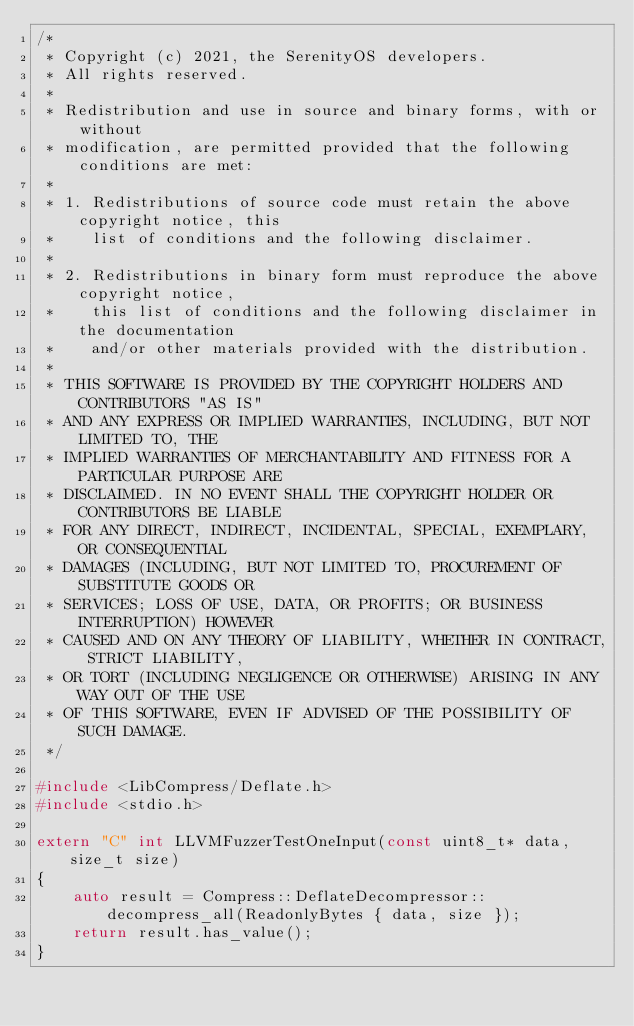Convert code to text. <code><loc_0><loc_0><loc_500><loc_500><_C++_>/*
 * Copyright (c) 2021, the SerenityOS developers.
 * All rights reserved.
 *
 * Redistribution and use in source and binary forms, with or without
 * modification, are permitted provided that the following conditions are met:
 *
 * 1. Redistributions of source code must retain the above copyright notice, this
 *    list of conditions and the following disclaimer.
 *
 * 2. Redistributions in binary form must reproduce the above copyright notice,
 *    this list of conditions and the following disclaimer in the documentation
 *    and/or other materials provided with the distribution.
 *
 * THIS SOFTWARE IS PROVIDED BY THE COPYRIGHT HOLDERS AND CONTRIBUTORS "AS IS"
 * AND ANY EXPRESS OR IMPLIED WARRANTIES, INCLUDING, BUT NOT LIMITED TO, THE
 * IMPLIED WARRANTIES OF MERCHANTABILITY AND FITNESS FOR A PARTICULAR PURPOSE ARE
 * DISCLAIMED. IN NO EVENT SHALL THE COPYRIGHT HOLDER OR CONTRIBUTORS BE LIABLE
 * FOR ANY DIRECT, INDIRECT, INCIDENTAL, SPECIAL, EXEMPLARY, OR CONSEQUENTIAL
 * DAMAGES (INCLUDING, BUT NOT LIMITED TO, PROCUREMENT OF SUBSTITUTE GOODS OR
 * SERVICES; LOSS OF USE, DATA, OR PROFITS; OR BUSINESS INTERRUPTION) HOWEVER
 * CAUSED AND ON ANY THEORY OF LIABILITY, WHETHER IN CONTRACT, STRICT LIABILITY,
 * OR TORT (INCLUDING NEGLIGENCE OR OTHERWISE) ARISING IN ANY WAY OUT OF THE USE
 * OF THIS SOFTWARE, EVEN IF ADVISED OF THE POSSIBILITY OF SUCH DAMAGE.
 */

#include <LibCompress/Deflate.h>
#include <stdio.h>

extern "C" int LLVMFuzzerTestOneInput(const uint8_t* data, size_t size)
{
    auto result = Compress::DeflateDecompressor::decompress_all(ReadonlyBytes { data, size });
    return result.has_value();
}
</code> 